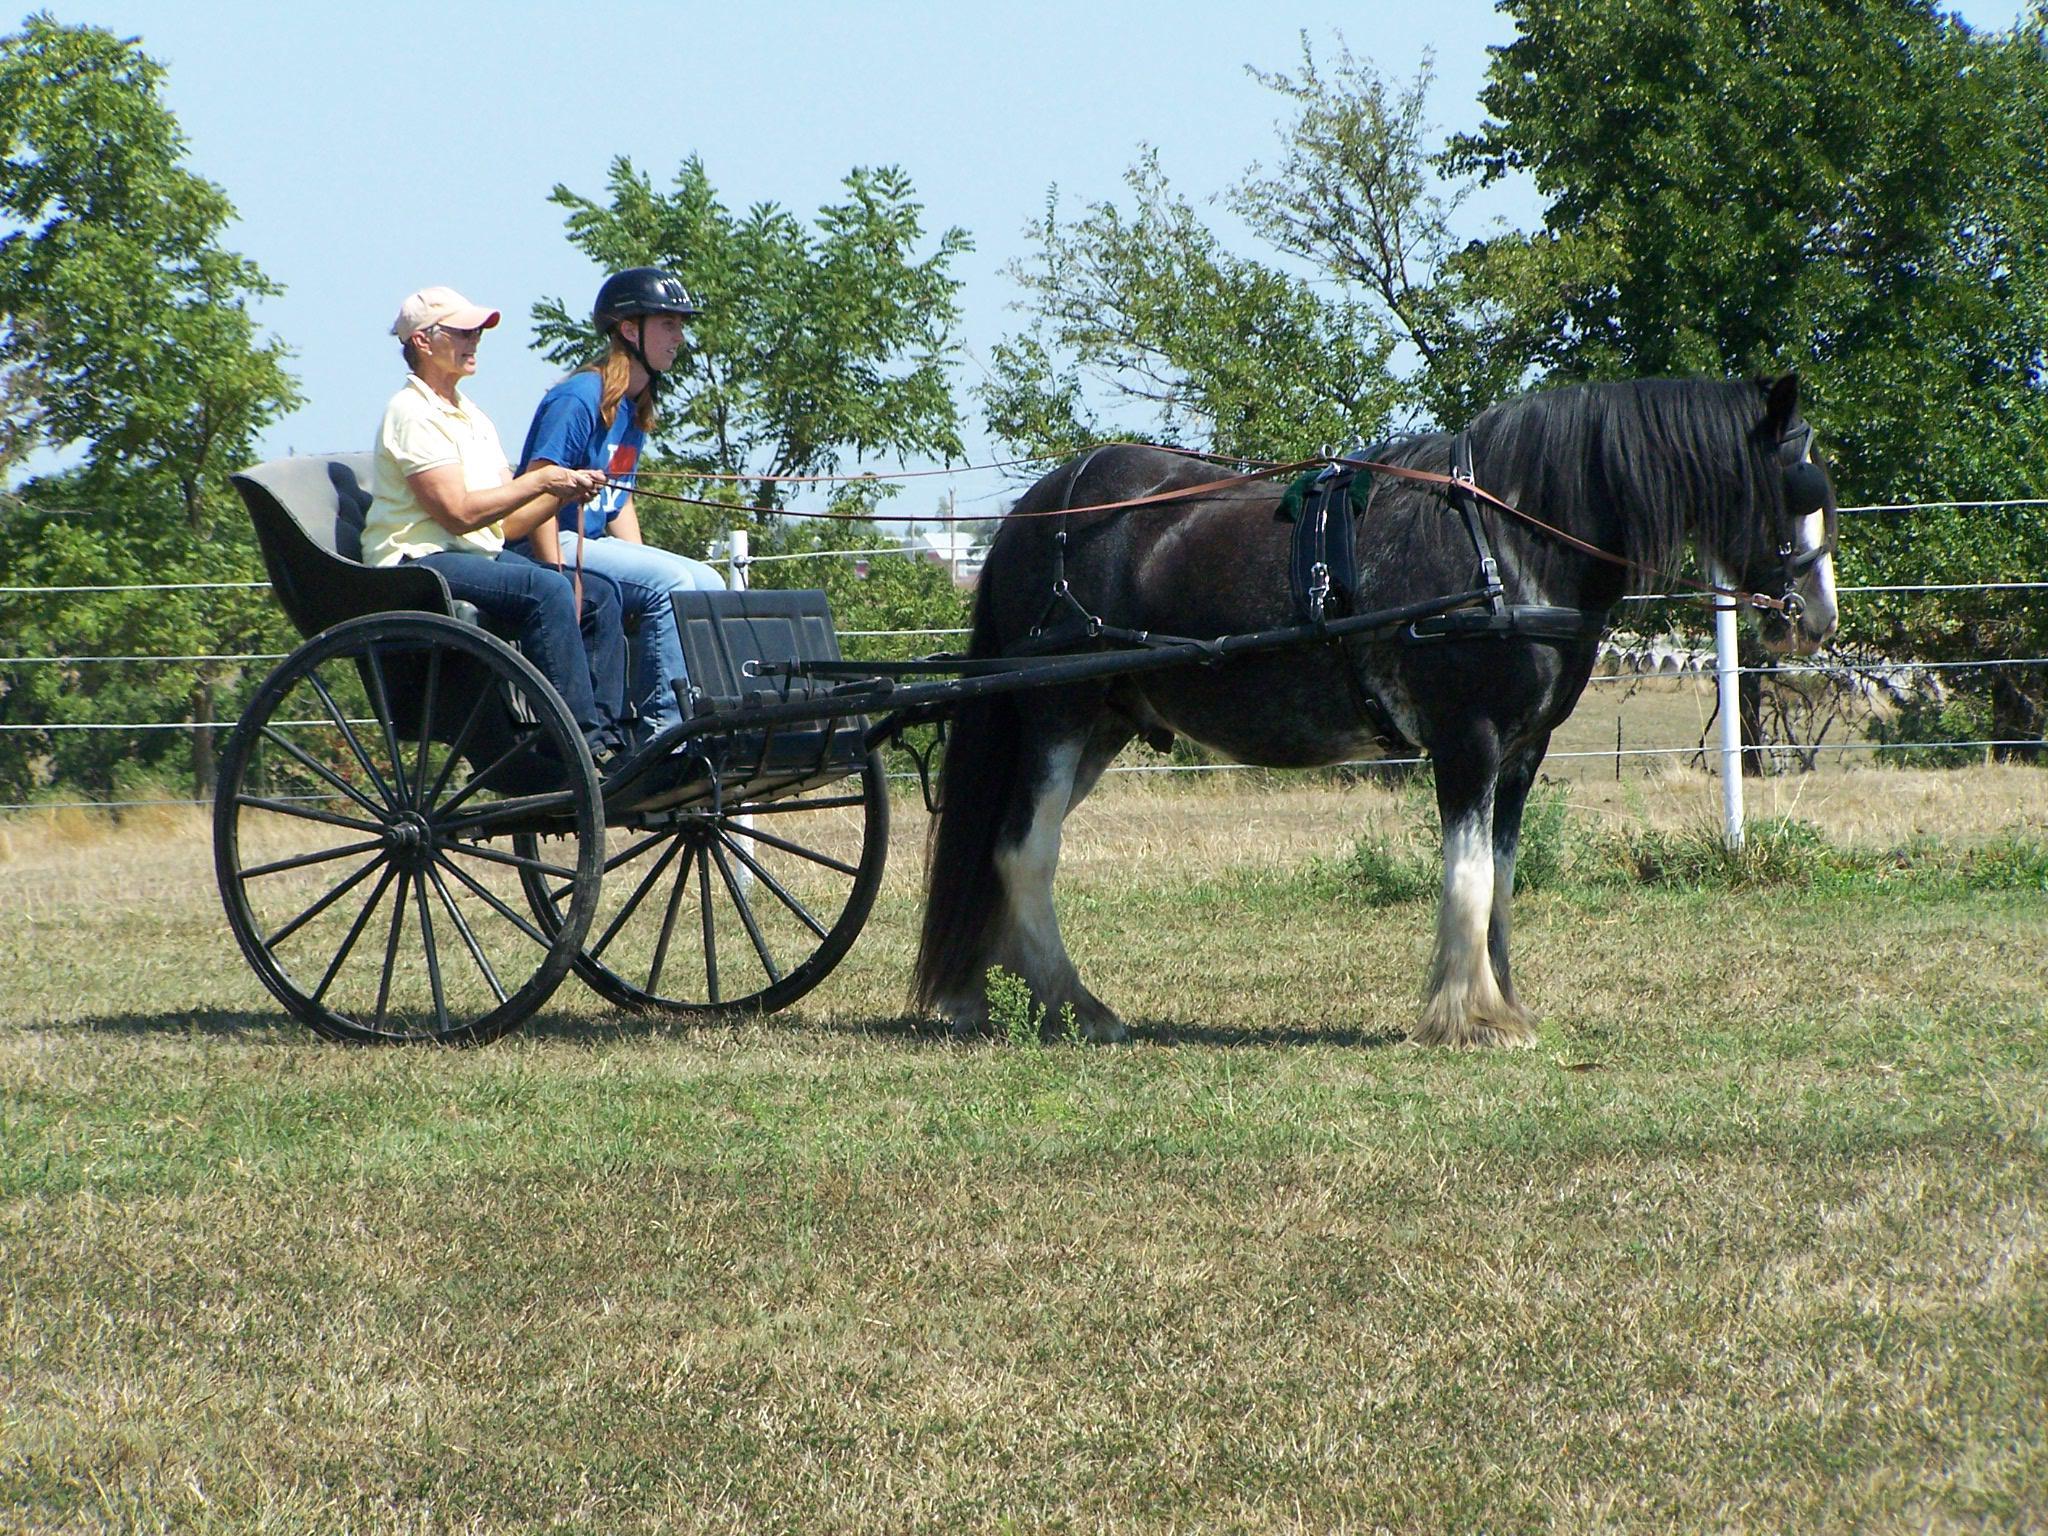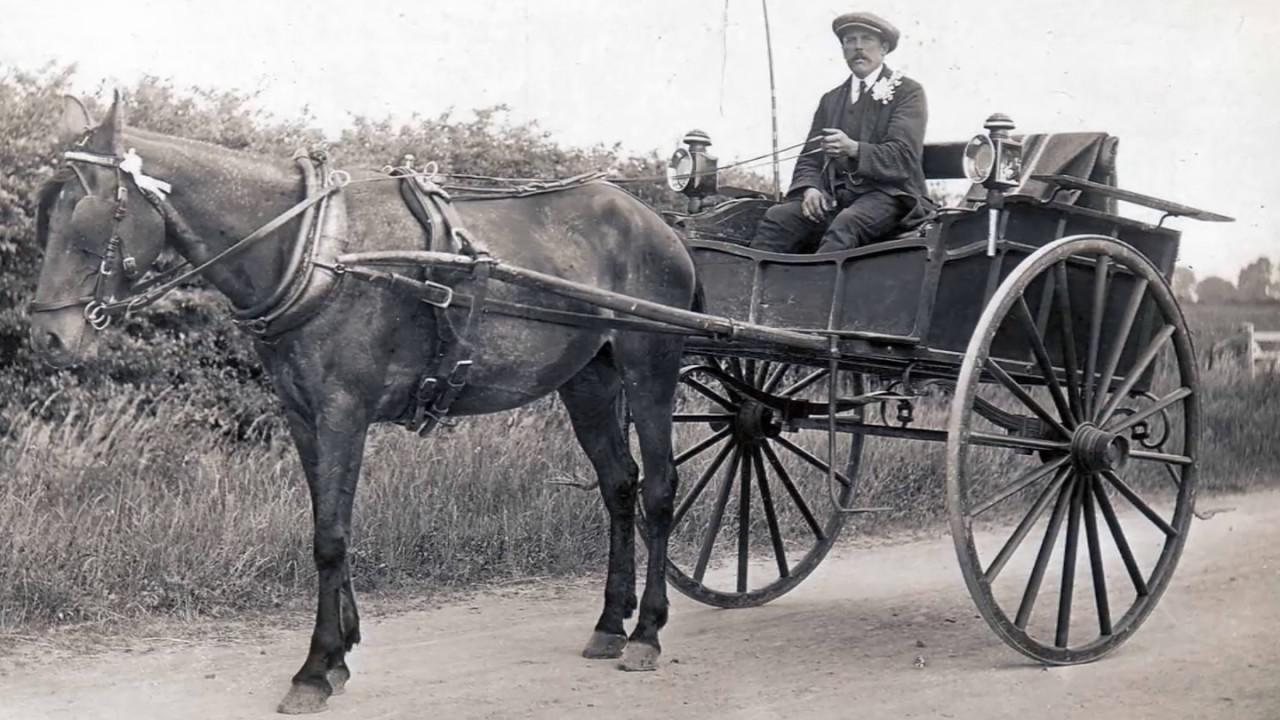The first image is the image on the left, the second image is the image on the right. For the images displayed, is the sentence "At least one carriage is being pulled by a horse." factually correct? Answer yes or no. Yes. The first image is the image on the left, the second image is the image on the right. Considering the images on both sides, is "At least one buggy is attached to a horse." valid? Answer yes or no. Yes. 